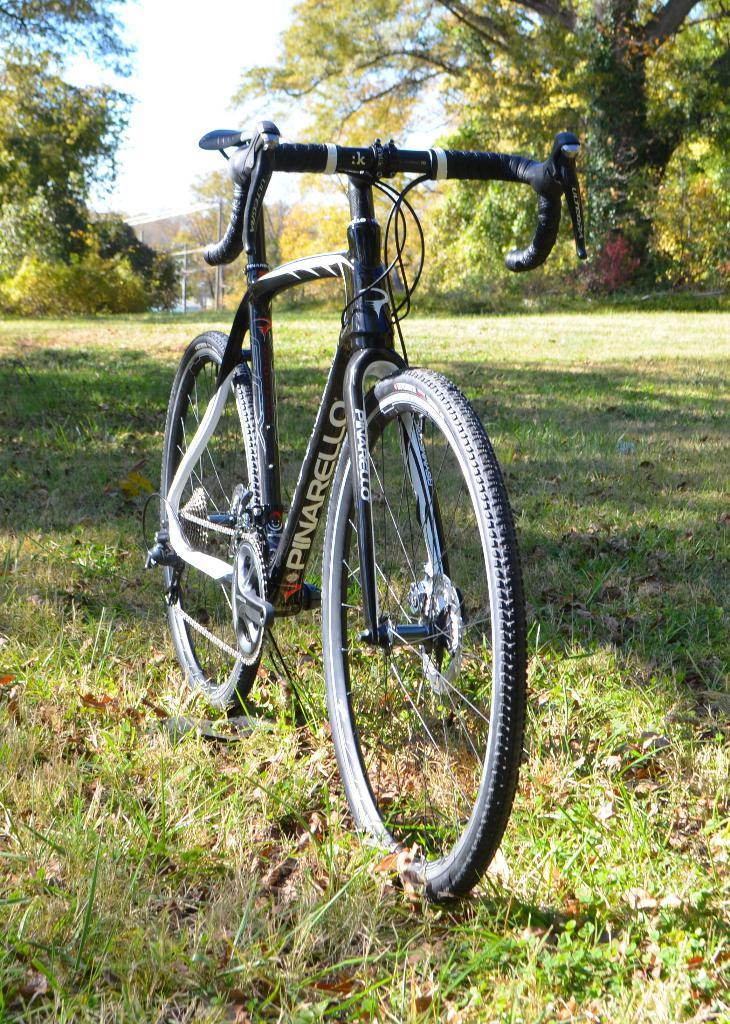What is the main subject in the foreground of the image? There is a bicycle in the foreground of the image. Where is the bicycle located? The bicycle is on the grass. What can be seen in the background of the image? There are trees, a building, and the sky visible in the background of the image. How many apples are hanging from the trees in the image? There are no apples visible in the image; only trees, a building, and the sky can be seen in the background. 